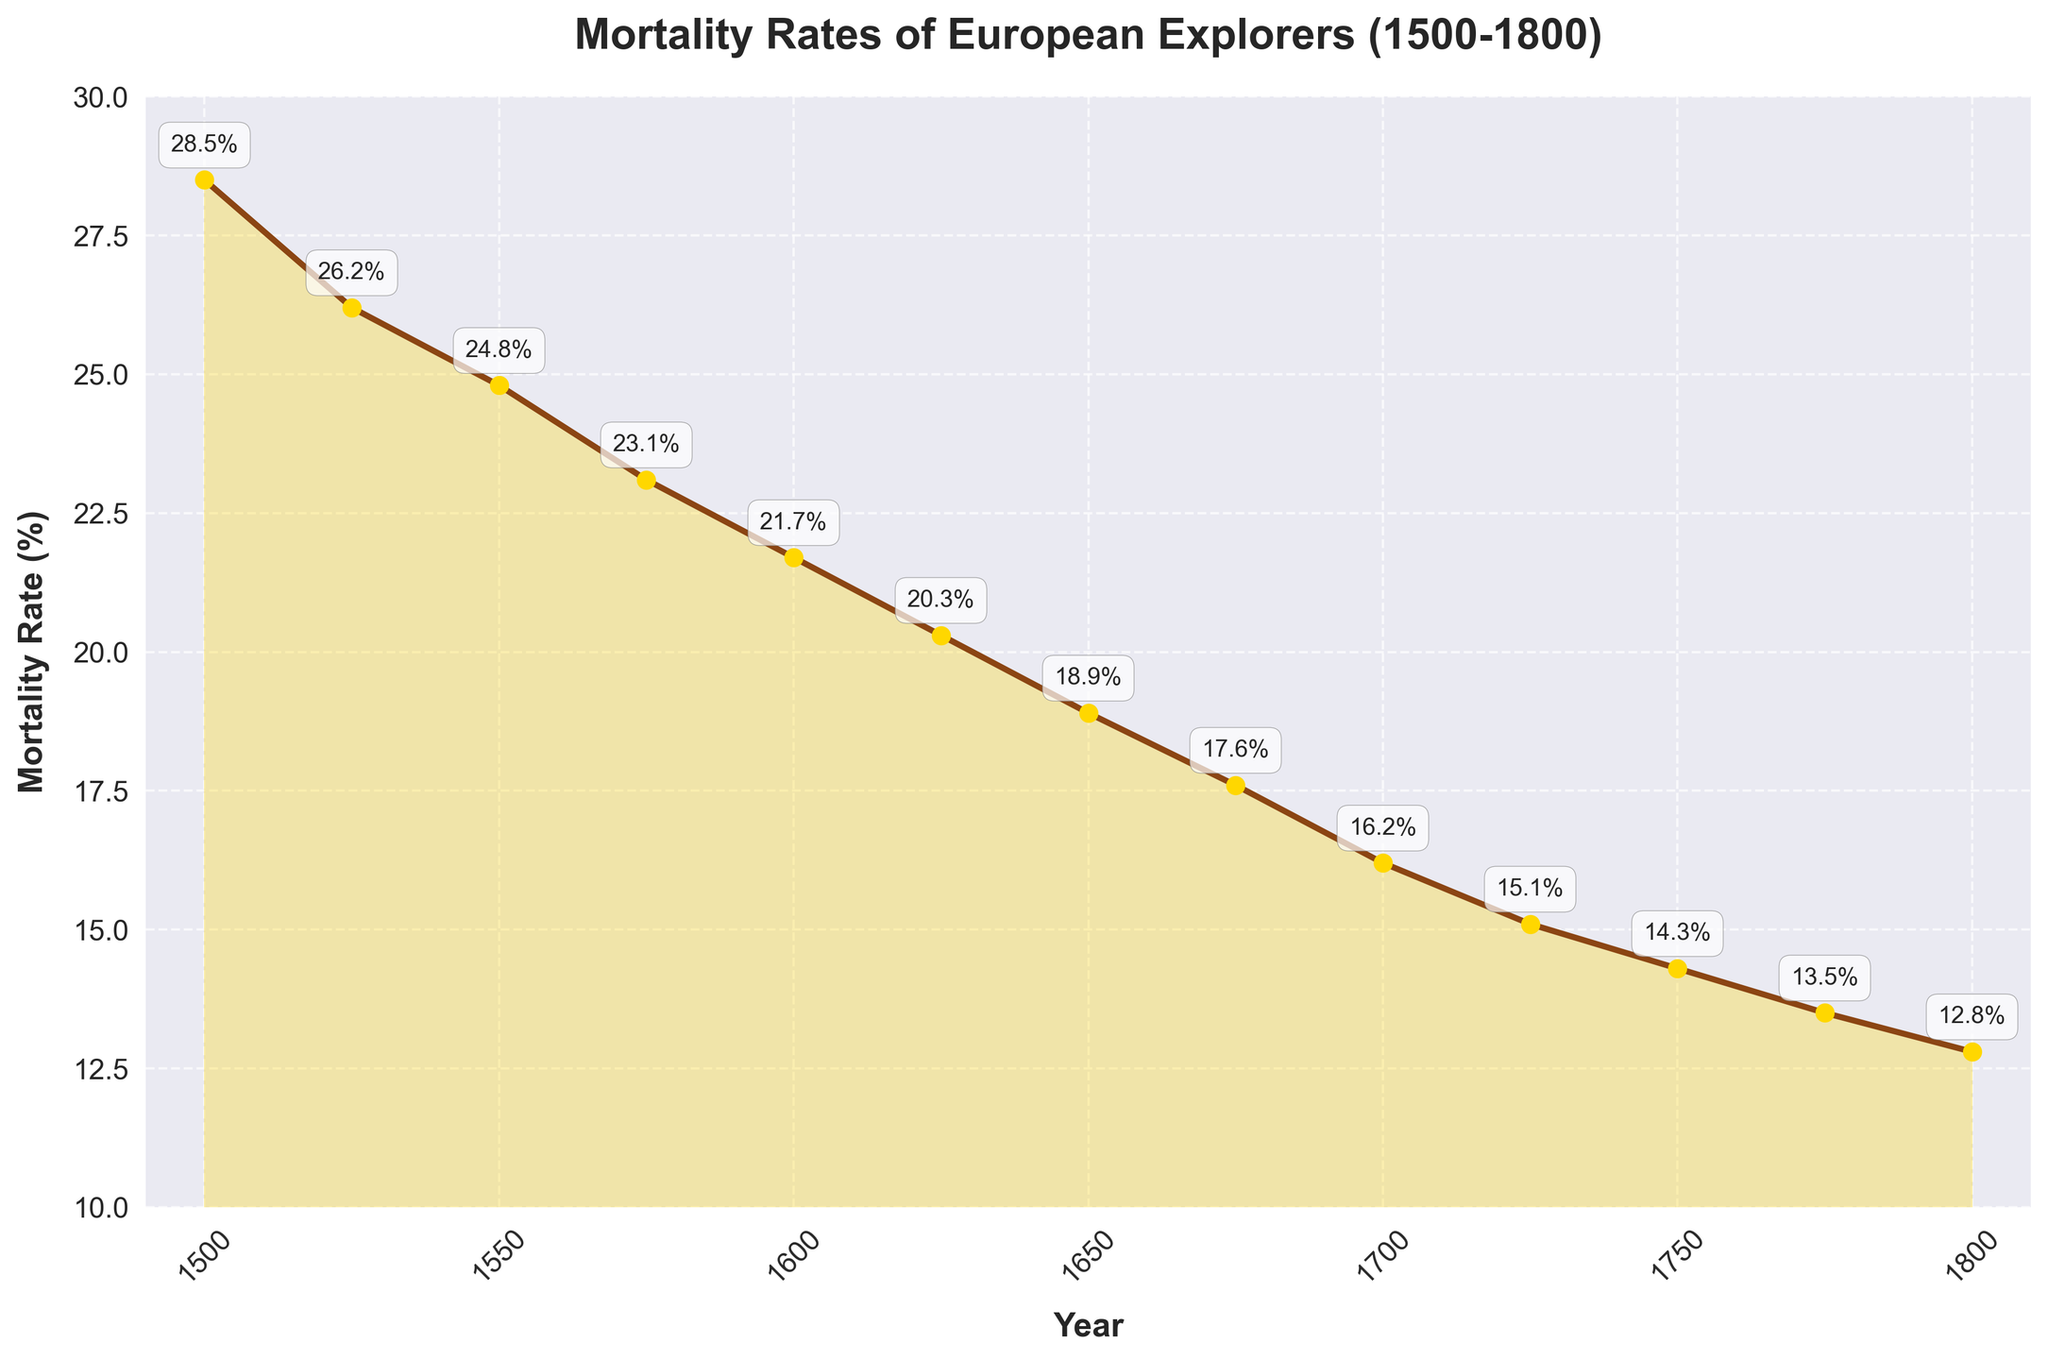What's the overall trend in mortality rates between 1500 and 1800? The figure shows a decreasing trend in mortality rates over the recorded period. The plot line consistently slopes downward from 28.5% in 1500 to 12.8% in 1800, indicating that the mortality rates progressively decreased.
Answer: Decreasing trend How much did the mortality rate change from 1500 to 1600? To find the change in mortality rate from 1500 to 1600, subtract the mortality rate in 1600 (21.7%) from the rate in 1500 (28.5%). Thus, 28.5% - 21.7% = 6.8%.
Answer: 6.8% What is the average mortality rate over the entire period shown? Sum up all the mortality rates from 1500 to 1800 and divide by the number of data points (13). The sum is 28.5 + 26.2 + 24.8 + 23.1 + 21.7 + 20.3 + 18.9 + 17.6 + 16.2 + 15.1 + 14.3 + 13.5 + 12.8 = 263.0. Thus, the average is 263.0 / 13 = 20.23%.
Answer: 20.23% Which year had the lowest mortality rate? By inspecting the plot, the year with the lowest mortality rate is 1800, where the rate is 12.8%.
Answer: 1800 Compare the mortality rates in 1600 and 1700. Which one is higher and by how much? The mortality rate in 1600 is 21.7%, while in 1700 it is 16.2%. 21.7% - 16.2% = 5.5%, so the rate in 1600 is higher by 5.5%.
Answer: 5.5% By what percentage did the mortality rate decrease from 1500 to 1800? First, find the initial and final values, which are 28.5% in 1500 and 12.8% in 1800. Calculate the decrease as 28.5% - 12.8% = 15.7%. Then, divide this decrease by the initial value (28.5%) and multiply by 100 to get the percentage decrease: (15.7 / 28.5) * 100 ≈ 55.1%.
Answer: 55.1% What is the difference in mortality rates between the midpoints of the periods 1500-1600 and 1600-1800? The midpoints of the periods are 1550 and 1700. The mortality rates at these points are 24.8% and 16.2%, respectively. The difference is 24.8% - 16.2% = 8.6%.
Answer: 8.6% Identify the periods where mortality rates dropped by at least 5% and name the corresponding years. Inspect the line chart for drops of at least 5%. From 1500 to 1600, the drop is 28.5% - 21.7% = 6.8%. From 1700 to 1775, the drop is 16.2% - 13.5% = 2.7%, however, this is less than 5%. The only significant drop is from 1500 to 1600.
Answer: 1500 to 1600 What visual characteristics indicate the trend in mortality rates over the shown period? The downward slope of the line connecting the data points and the shaded area below the line both visually indicate a decreasing trend over time. Additionally, the annotations with decreasing percentages further emphasize this trend.
Answer: Downward sloping line and shaded area 